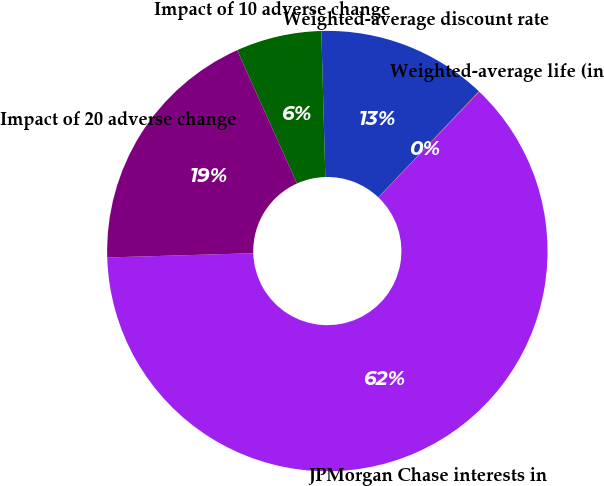<chart> <loc_0><loc_0><loc_500><loc_500><pie_chart><fcel>JPMorgan Chase interests in<fcel>Weighted-average life (in<fcel>Weighted-average discount rate<fcel>Impact of 10 adverse change<fcel>Impact of 20 adverse change<nl><fcel>62.42%<fcel>0.04%<fcel>12.51%<fcel>6.28%<fcel>18.75%<nl></chart> 